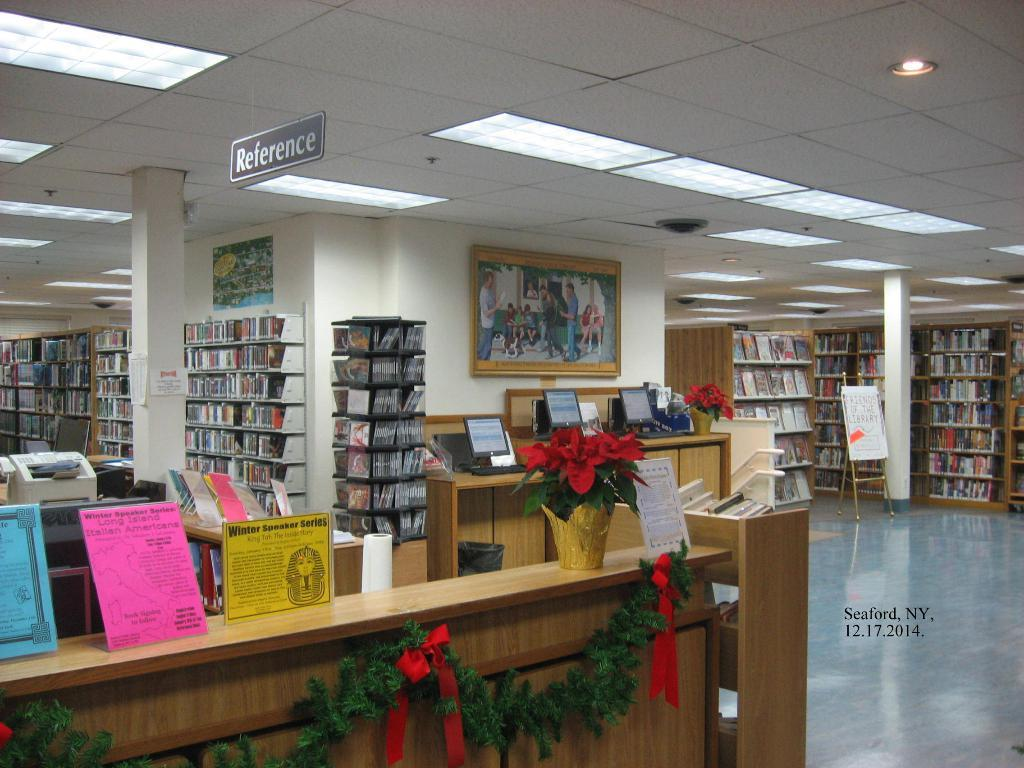<image>
Render a clear and concise summary of the photo. Public library reference desk located in Seaford, New York on 12/17/2014 